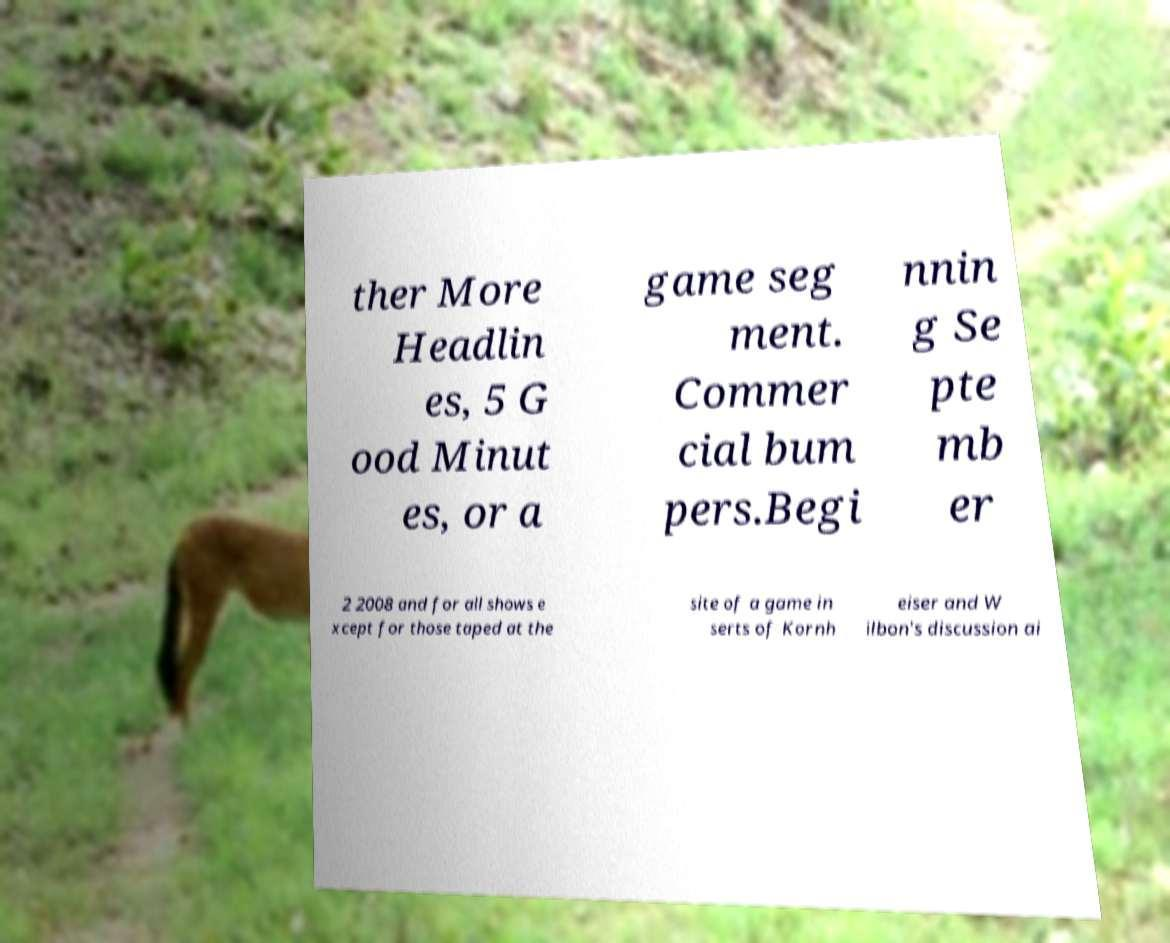Could you assist in decoding the text presented in this image and type it out clearly? ther More Headlin es, 5 G ood Minut es, or a game seg ment. Commer cial bum pers.Begi nnin g Se pte mb er 2 2008 and for all shows e xcept for those taped at the site of a game in serts of Kornh eiser and W ilbon's discussion ai 